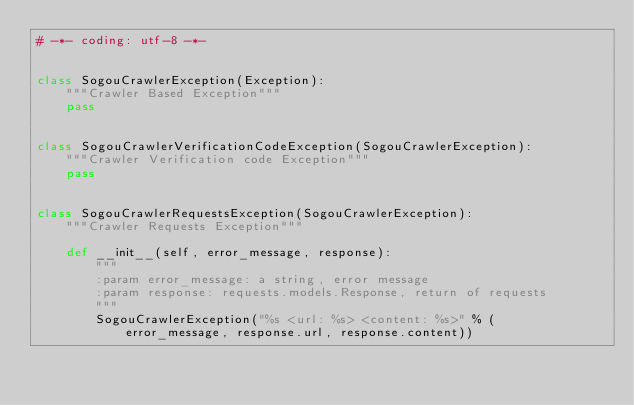Convert code to text. <code><loc_0><loc_0><loc_500><loc_500><_Python_># -*- coding: utf-8 -*-


class SogouCrawlerException(Exception):
    """Crawler Based Exception"""
    pass


class SogouCrawlerVerificationCodeException(SogouCrawlerException):
    """Crawler Verification code Exception"""
    pass


class SogouCrawlerRequestsException(SogouCrawlerException):
    """Crawler Requests Exception"""

    def __init__(self, error_message, response):
        """
        :param error_message: a string, error message
        :param response: requests.models.Response, return of requests
        """
        SogouCrawlerException("%s <url: %s> <content: %s>" % (
            error_message, response.url, response.content))
</code> 